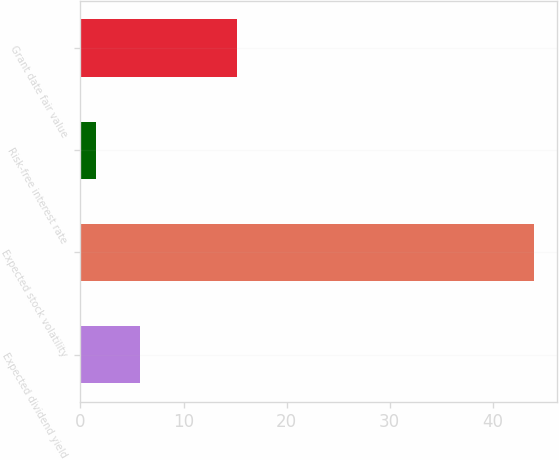Convert chart. <chart><loc_0><loc_0><loc_500><loc_500><bar_chart><fcel>Expected dividend yield<fcel>Expected stock volatility<fcel>Risk-free interest rate<fcel>Grant date fair value<nl><fcel>5.79<fcel>44<fcel>1.55<fcel>15.19<nl></chart> 